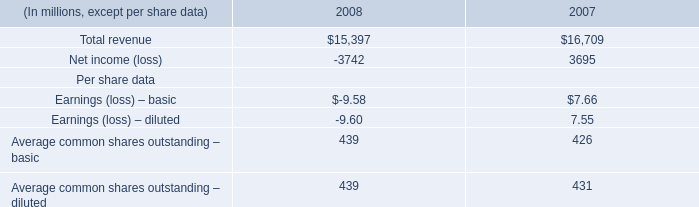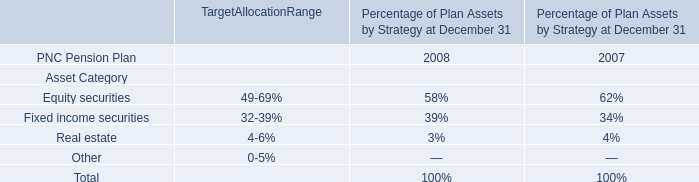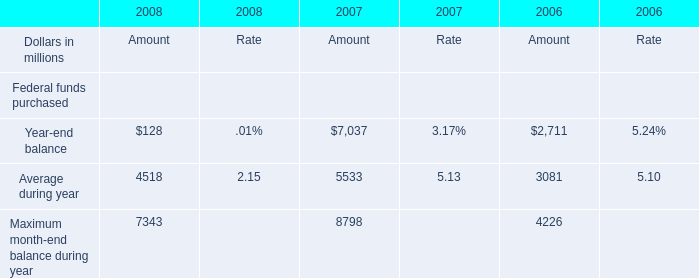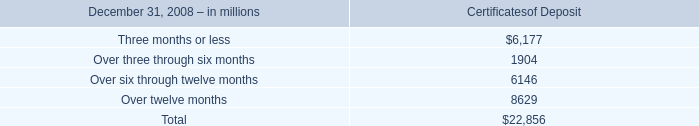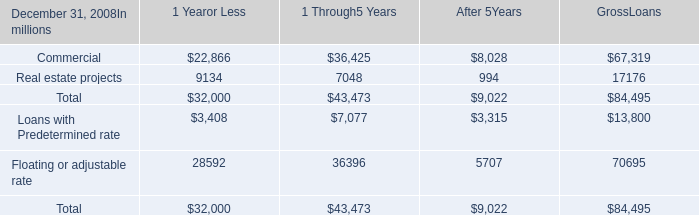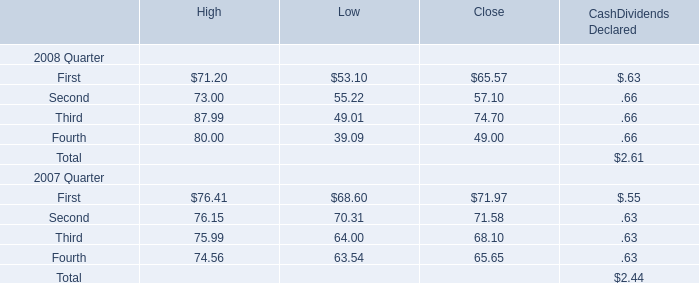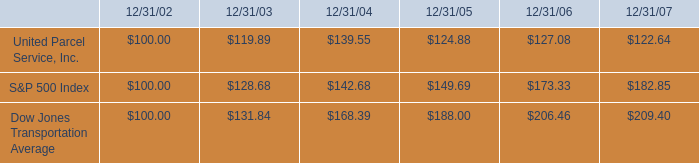what is the rate of return of an investment in ups from 2003 to 2004? 
Computations: ((139.55 - 119.89) / 119.89)
Answer: 0.16398. 